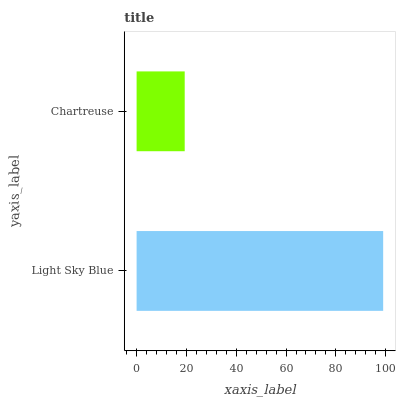Is Chartreuse the minimum?
Answer yes or no. Yes. Is Light Sky Blue the maximum?
Answer yes or no. Yes. Is Chartreuse the maximum?
Answer yes or no. No. Is Light Sky Blue greater than Chartreuse?
Answer yes or no. Yes. Is Chartreuse less than Light Sky Blue?
Answer yes or no. Yes. Is Chartreuse greater than Light Sky Blue?
Answer yes or no. No. Is Light Sky Blue less than Chartreuse?
Answer yes or no. No. Is Light Sky Blue the high median?
Answer yes or no. Yes. Is Chartreuse the low median?
Answer yes or no. Yes. Is Chartreuse the high median?
Answer yes or no. No. Is Light Sky Blue the low median?
Answer yes or no. No. 